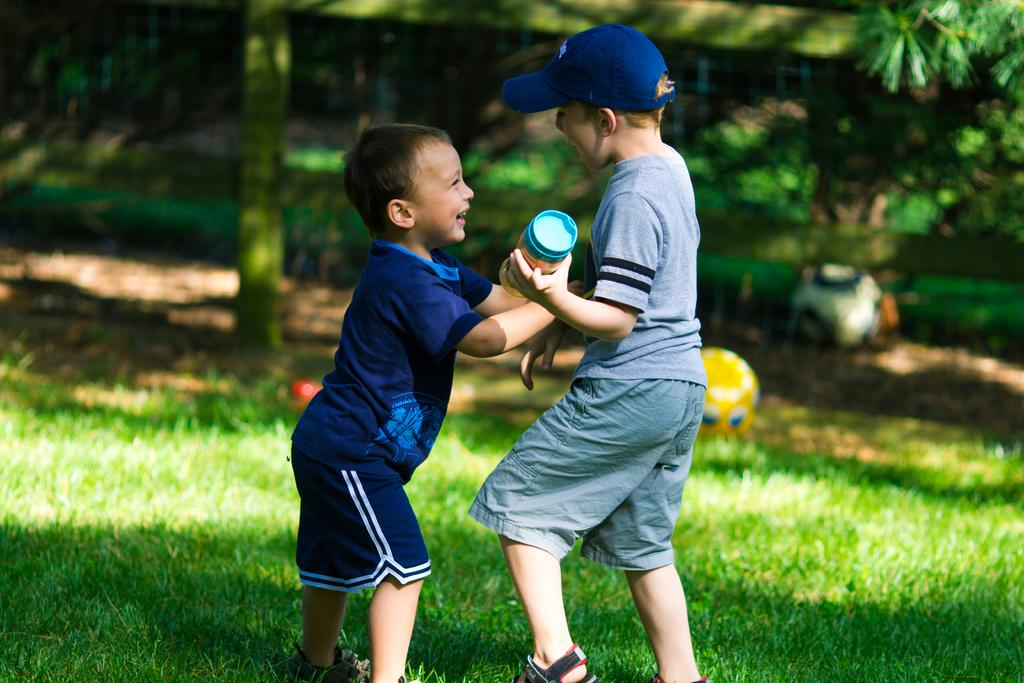How many kids are present in the image? There are two kids in the image. What are the kids doing in the image? The kids are standing in the image. What are the kids holding in the image? The kids are holding something in the image. What can be seen in the background of the image? There are plants, grass, and trees in the background of the image. What type of apparel is the kids wearing in the image? The provided facts do not mention the type of apparel the kids are wearing in the image. What prints can be seen on the boats in the image? There are no boats present in the image. 